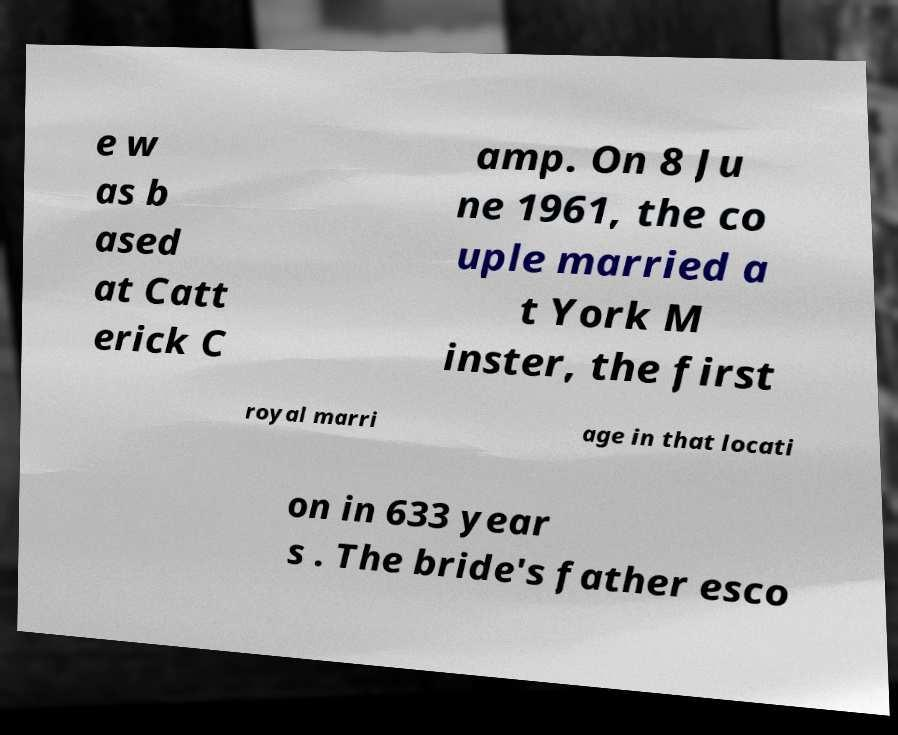Can you accurately transcribe the text from the provided image for me? e w as b ased at Catt erick C amp. On 8 Ju ne 1961, the co uple married a t York M inster, the first royal marri age in that locati on in 633 year s . The bride's father esco 